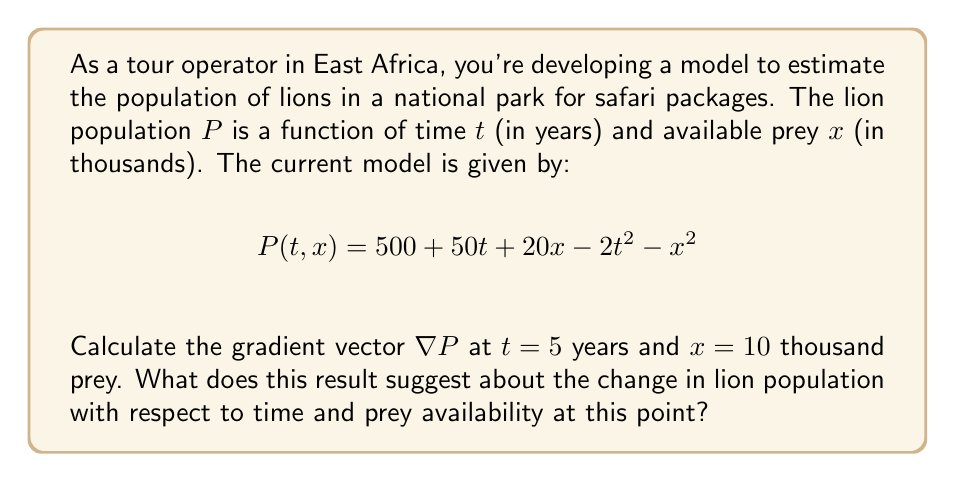Solve this math problem. To solve this problem, we'll follow these steps:

1) First, we need to calculate the gradient vector $\nabla P$. The gradient is a vector of partial derivatives:

   $$\nabla P = \left(\frac{\partial P}{\partial t}, \frac{\partial P}{\partial x}\right)$$

2) Let's calculate each partial derivative:

   $$\frac{\partial P}{\partial t} = 50 - 4t$$
   $$\frac{\partial P}{\partial x} = 20 - 2x$$

3) Now we have the gradient vector:

   $$\nabla P = (50 - 4t, 20 - 2x)$$

4) We need to evaluate this at $t=5$ and $x=10$:

   $$\nabla P|_{(5,10)} = (50 - 4(5), 20 - 2(10))$$
   $$= (50 - 20, 20 - 20)$$
   $$= (30, 0)$$

5) Interpretation of the result:
   - The first component (30) represents the rate of change of the lion population with respect to time. It's positive, indicating the population is increasing with time at this point.
   - The second component (0) represents the rate of change of the lion population with respect to prey availability. It's zero, suggesting that at this point, small changes in prey availability won't significantly affect the lion population.

This information is valuable for safari tour planning, as it suggests that the lion population is growing over time, which could lead to better wildlife viewing opportunities. However, at this particular point, changes in prey availability aren't significantly impacting the lion population.
Answer: $\nabla P|_{(5,10)} = (30, 0)$ 